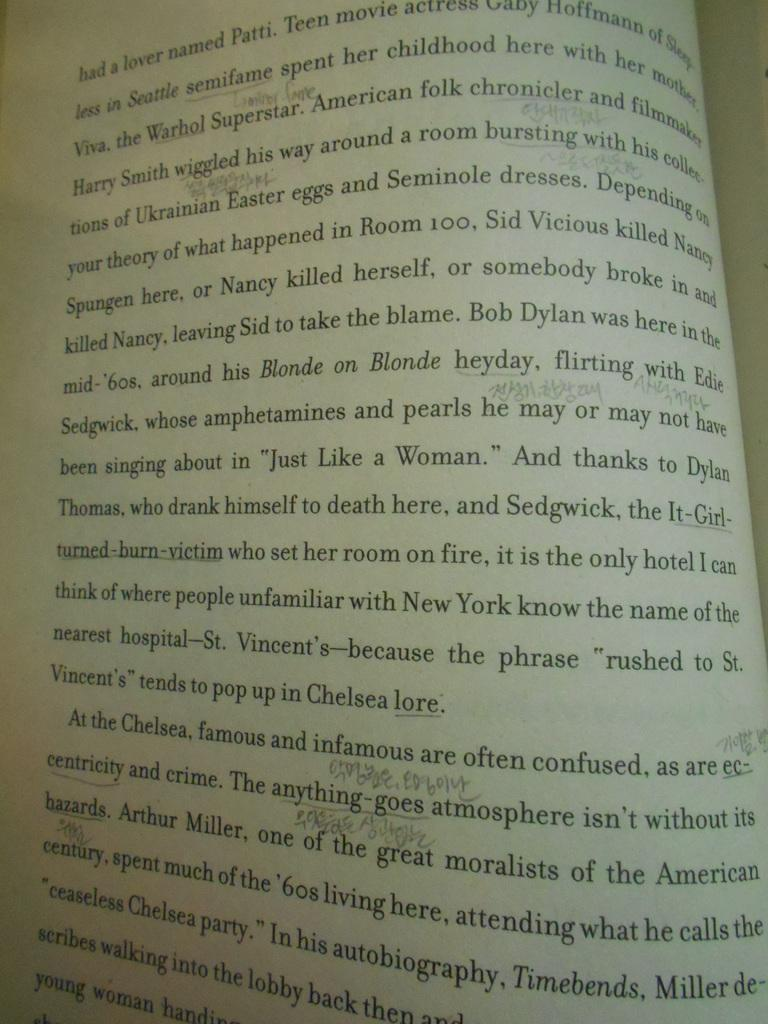<image>
Share a concise interpretation of the image provided. The book that is open here takes place in New York 